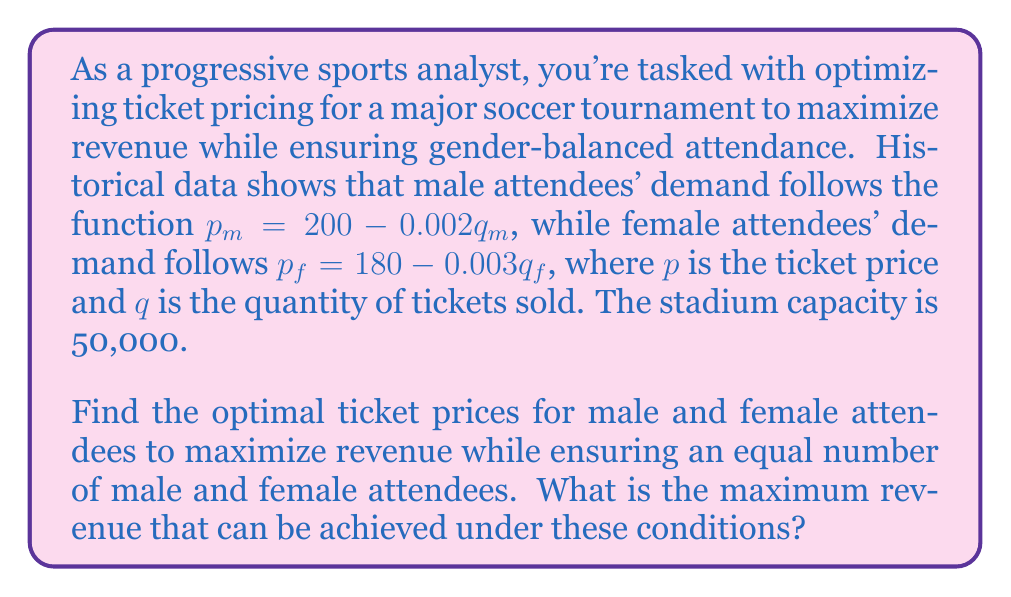Show me your answer to this math problem. To solve this problem, we'll follow these steps:

1) First, we need to ensure equal attendance for both genders:
   $q_m = q_f = q$

2) Now, we can express the prices in terms of $q$:
   $p_m = 200 - 0.002q$
   $p_f = 180 - 0.003q$

3) The total revenue $R$ is the sum of revenue from both groups:
   $R = p_m q + p_f q = (200 - 0.002q)q + (180 - 0.003q)q$
   $R = 380q - 0.005q^2$

4) To maximize revenue, we differentiate $R$ with respect to $q$ and set it to zero:
   $\frac{dR}{dq} = 380 - 0.01q = 0$
   $380 - 0.01q = 0$
   $q = 38,000$

5) Since the stadium capacity is 50,000, this solution is feasible.

6) Now we can calculate the optimal prices:
   $p_m = 200 - 0.002(38,000) = 124$
   $p_f = 180 - 0.003(38,000) = 66$

7) The maximum revenue is:
   $R = 124(38,000) + 66(38,000) = 7,220,000$

Therefore, the optimal ticket price for male attendees is $124, for female attendees is $66, and the maximum revenue is $7,220,000.
Answer: Optimal ticket price for male attendees: $124
Optimal ticket price for female attendees: $66
Maximum revenue: $7,220,000 